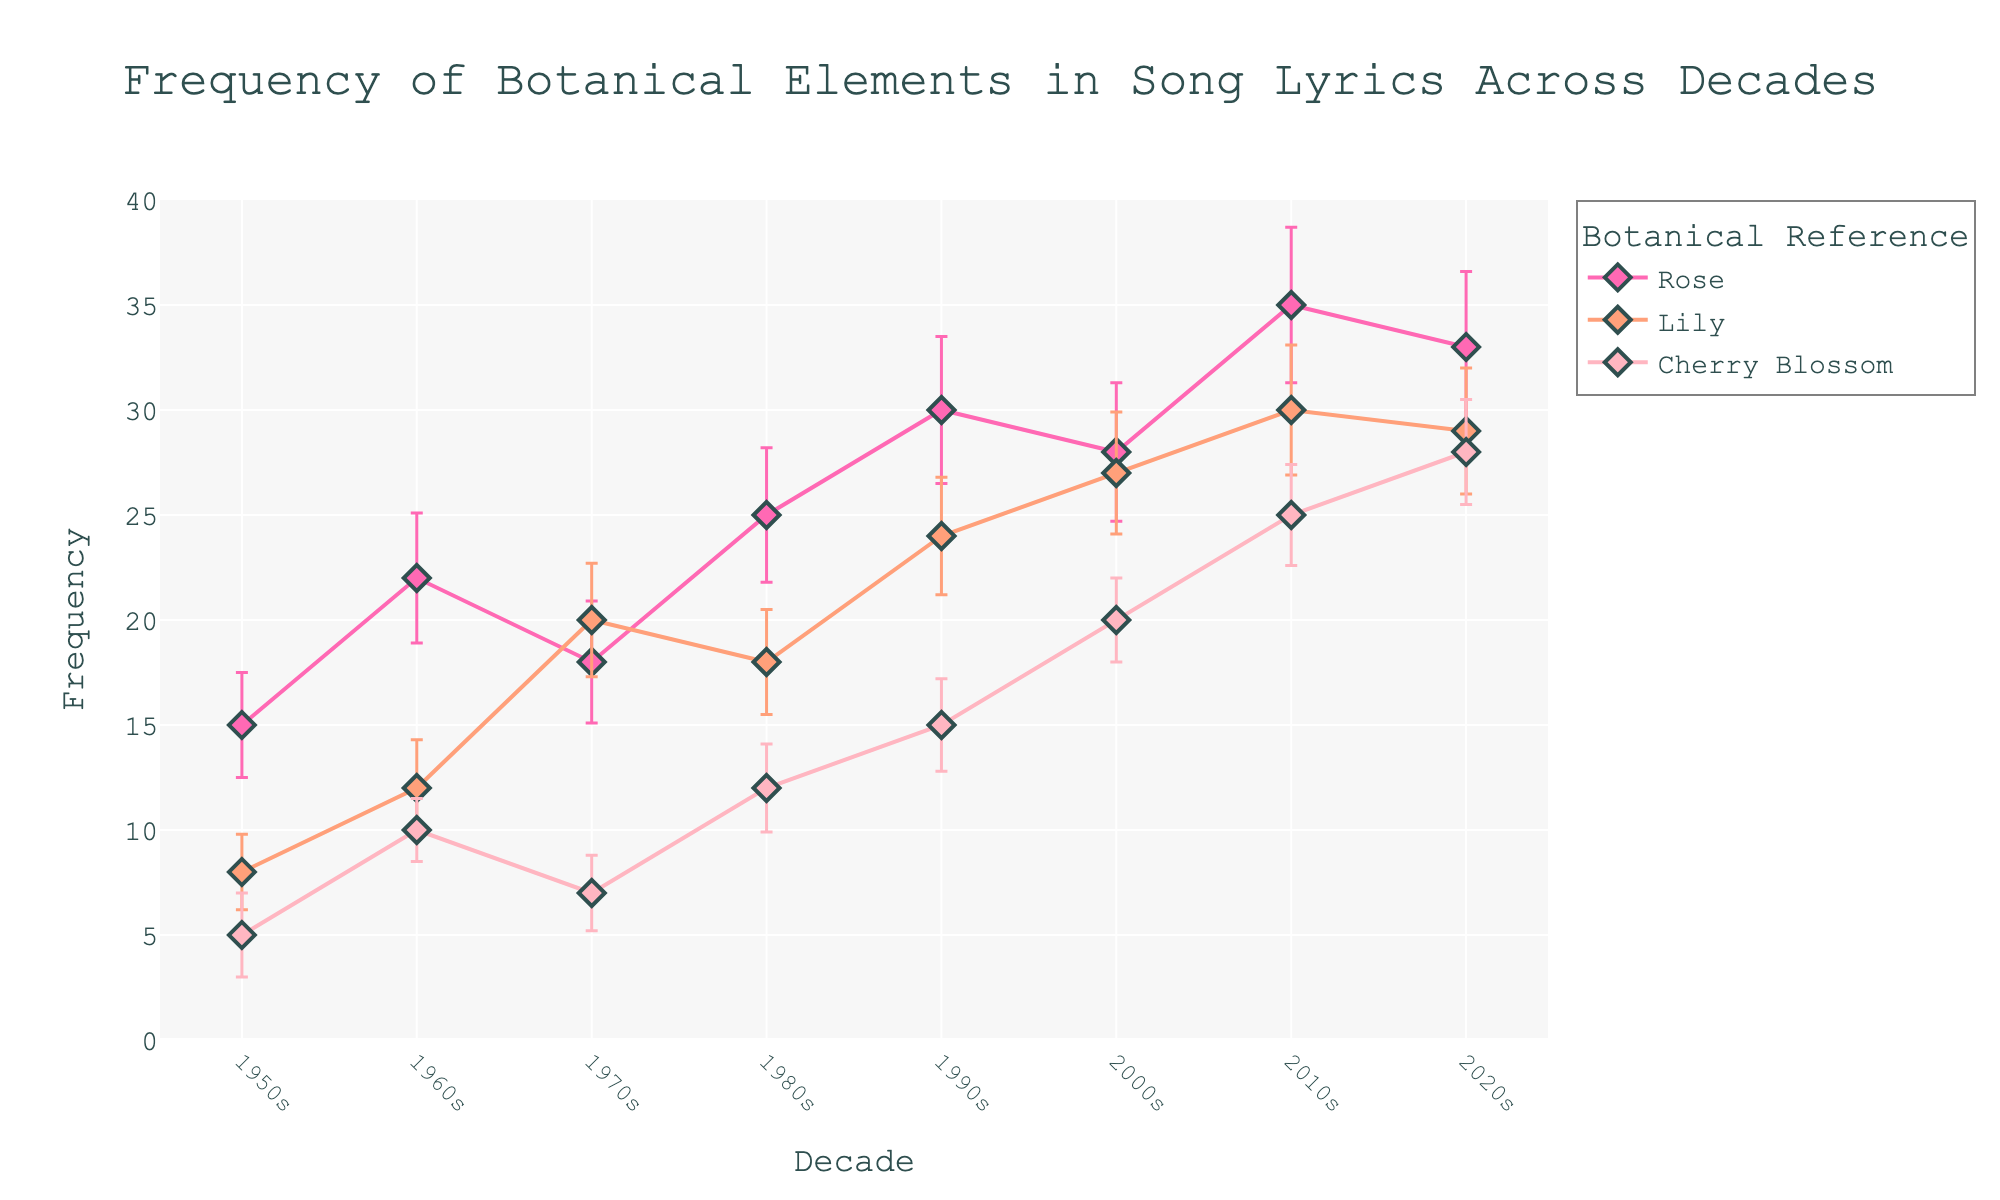What's the title of the figure? The title of the figure is prominently displayed at the top.
Answer: Frequency of Botanical Elements in Song Lyrics Across Decades What is the botanical reference with the highest frequency in the 1970s? By observing the data points in the 1970s, the highest frequency belongs to Lily.
Answer: Lily How does the frequency of Rose references change from the 1950s to the 2020s? We look at the frequency of Rose in each decade and see that it generally increases over time, peaking in the 2010s before slightly dropping in the 2020s.
Answer: Increases and then slightly decreases Which botanical reference has the smallest standard deviation in the 1960s? By examining the error bars in the 1960s, Cherry Blossom has the smallest standard deviation.
Answer: Cherry Blossom In which decade did Cherry Blossom see its highest frequency? Check the frequency points for Cherry Blossom across all decades. The highest frequency is in the 2020s.
Answer: 2020s What trend do you observe for Lily from the 2000s to the 2020s? From the frequency points between the 2000s and the 2020s, Lily shows a slight decrease in frequency.
Answer: Decreases slightly Which decade shows the largest spread in the frequencies of botanical references based on standard deviations? The size of the error bars across the decades indicates the spread. The 1980s show the largest spread with the largest error bars.
Answer: 1980s Arrange the frequency of Rose from the 1950s to the 2020s in ascending order. Examine the frequency of Rose in each decade and sort them. Order is: 1950s (15), 1970s (18), 1960s (22), 1980s (25), 2000s (28), 2020s (33), 2010s (35), 1990s (30)
Answer: 15, 18, 22, 25, 28, 30, 33, 35 In which decade did the frequency of Lily surpass Rose? Compare the plot lines of Lily and Rose in each decade. In the 1970s, Lily's frequency (20) is higher than Rose's (18).
Answer: 1970s 